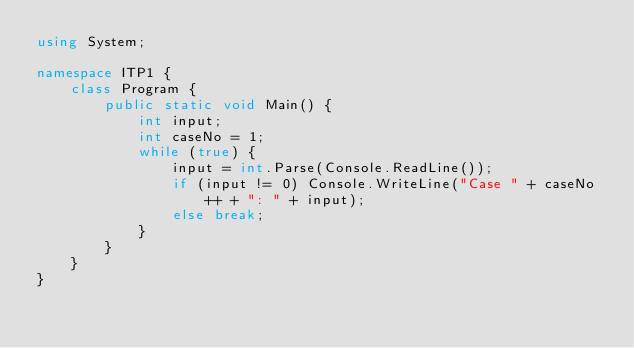Convert code to text. <code><loc_0><loc_0><loc_500><loc_500><_C#_>using System;

namespace ITP1 {
	class Program {
		public static void Main() {
			int input;
			int caseNo = 1;
			while (true) {
				input = int.Parse(Console.ReadLine());
				if (input != 0) Console.WriteLine("Case " + caseNo++ + ": " + input);
				else break;
			}
		}
	}
}

</code> 